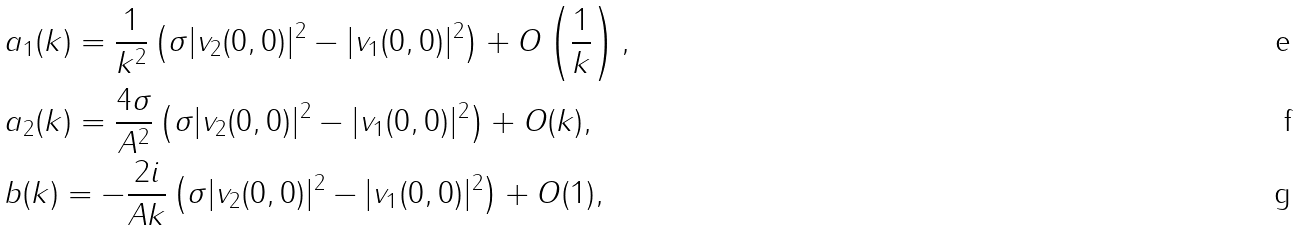Convert formula to latex. <formula><loc_0><loc_0><loc_500><loc_500>& a _ { 1 } ( k ) = \frac { 1 } { k ^ { 2 } } \left ( \sigma | v _ { 2 } ( 0 , 0 ) | ^ { 2 } - | v _ { 1 } ( 0 , 0 ) | ^ { 2 } \right ) + O \left ( \frac { 1 } { k } \right ) , \\ & a _ { 2 } ( k ) = \frac { 4 \sigma } { A ^ { 2 } } \left ( \sigma | v _ { 2 } ( 0 , 0 ) | ^ { 2 } - | v _ { 1 } ( 0 , 0 ) | ^ { 2 } \right ) + O ( k ) , \\ & b ( k ) = - \frac { 2 i } { A k } \left ( \sigma | v _ { 2 } ( 0 , 0 ) | ^ { 2 } - | v _ { 1 } ( 0 , 0 ) | ^ { 2 } \right ) + O ( 1 ) ,</formula> 